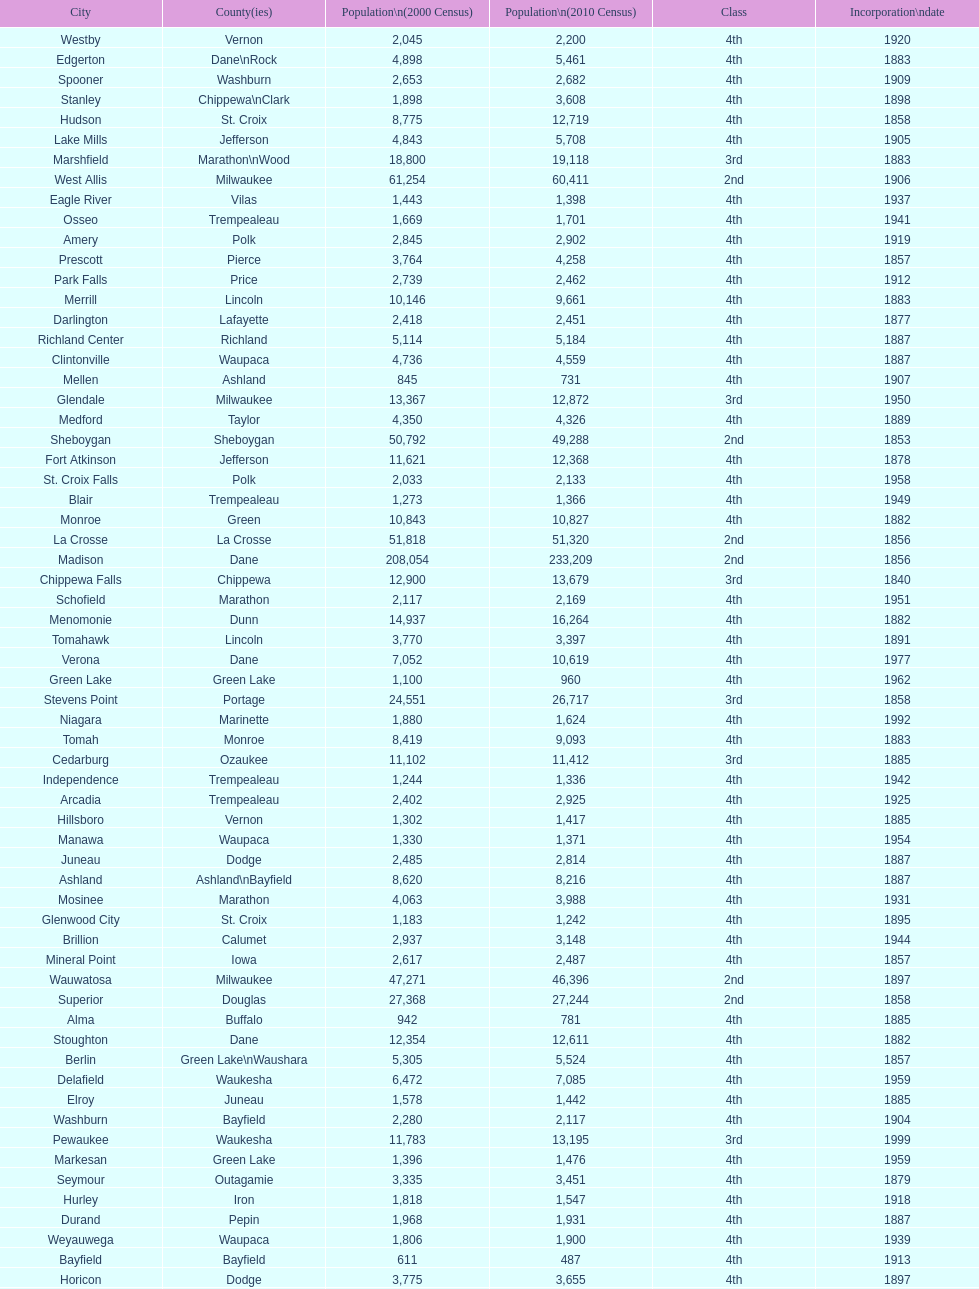Would you mind parsing the complete table? {'header': ['City', 'County(ies)', 'Population\\n(2000 Census)', 'Population\\n(2010 Census)', 'Class', 'Incorporation\\ndate'], 'rows': [['Westby', 'Vernon', '2,045', '2,200', '4th', '1920'], ['Edgerton', 'Dane\\nRock', '4,898', '5,461', '4th', '1883'], ['Spooner', 'Washburn', '2,653', '2,682', '4th', '1909'], ['Stanley', 'Chippewa\\nClark', '1,898', '3,608', '4th', '1898'], ['Hudson', 'St. Croix', '8,775', '12,719', '4th', '1858'], ['Lake Mills', 'Jefferson', '4,843', '5,708', '4th', '1905'], ['Marshfield', 'Marathon\\nWood', '18,800', '19,118', '3rd', '1883'], ['West Allis', 'Milwaukee', '61,254', '60,411', '2nd', '1906'], ['Eagle River', 'Vilas', '1,443', '1,398', '4th', '1937'], ['Osseo', 'Trempealeau', '1,669', '1,701', '4th', '1941'], ['Amery', 'Polk', '2,845', '2,902', '4th', '1919'], ['Prescott', 'Pierce', '3,764', '4,258', '4th', '1857'], ['Park Falls', 'Price', '2,739', '2,462', '4th', '1912'], ['Merrill', 'Lincoln', '10,146', '9,661', '4th', '1883'], ['Darlington', 'Lafayette', '2,418', '2,451', '4th', '1877'], ['Richland Center', 'Richland', '5,114', '5,184', '4th', '1887'], ['Clintonville', 'Waupaca', '4,736', '4,559', '4th', '1887'], ['Mellen', 'Ashland', '845', '731', '4th', '1907'], ['Glendale', 'Milwaukee', '13,367', '12,872', '3rd', '1950'], ['Medford', 'Taylor', '4,350', '4,326', '4th', '1889'], ['Sheboygan', 'Sheboygan', '50,792', '49,288', '2nd', '1853'], ['Fort Atkinson', 'Jefferson', '11,621', '12,368', '4th', '1878'], ['St. Croix Falls', 'Polk', '2,033', '2,133', '4th', '1958'], ['Blair', 'Trempealeau', '1,273', '1,366', '4th', '1949'], ['Monroe', 'Green', '10,843', '10,827', '4th', '1882'], ['La Crosse', 'La Crosse', '51,818', '51,320', '2nd', '1856'], ['Madison', 'Dane', '208,054', '233,209', '2nd', '1856'], ['Chippewa Falls', 'Chippewa', '12,900', '13,679', '3rd', '1840'], ['Schofield', 'Marathon', '2,117', '2,169', '4th', '1951'], ['Menomonie', 'Dunn', '14,937', '16,264', '4th', '1882'], ['Tomahawk', 'Lincoln', '3,770', '3,397', '4th', '1891'], ['Verona', 'Dane', '7,052', '10,619', '4th', '1977'], ['Green Lake', 'Green Lake', '1,100', '960', '4th', '1962'], ['Stevens Point', 'Portage', '24,551', '26,717', '3rd', '1858'], ['Niagara', 'Marinette', '1,880', '1,624', '4th', '1992'], ['Tomah', 'Monroe', '8,419', '9,093', '4th', '1883'], ['Cedarburg', 'Ozaukee', '11,102', '11,412', '3rd', '1885'], ['Independence', 'Trempealeau', '1,244', '1,336', '4th', '1942'], ['Arcadia', 'Trempealeau', '2,402', '2,925', '4th', '1925'], ['Hillsboro', 'Vernon', '1,302', '1,417', '4th', '1885'], ['Manawa', 'Waupaca', '1,330', '1,371', '4th', '1954'], ['Juneau', 'Dodge', '2,485', '2,814', '4th', '1887'], ['Ashland', 'Ashland\\nBayfield', '8,620', '8,216', '4th', '1887'], ['Mosinee', 'Marathon', '4,063', '3,988', '4th', '1931'], ['Glenwood City', 'St. Croix', '1,183', '1,242', '4th', '1895'], ['Brillion', 'Calumet', '2,937', '3,148', '4th', '1944'], ['Mineral Point', 'Iowa', '2,617', '2,487', '4th', '1857'], ['Wauwatosa', 'Milwaukee', '47,271', '46,396', '2nd', '1897'], ['Superior', 'Douglas', '27,368', '27,244', '2nd', '1858'], ['Alma', 'Buffalo', '942', '781', '4th', '1885'], ['Stoughton', 'Dane', '12,354', '12,611', '4th', '1882'], ['Berlin', 'Green Lake\\nWaushara', '5,305', '5,524', '4th', '1857'], ['Delafield', 'Waukesha', '6,472', '7,085', '4th', '1959'], ['Elroy', 'Juneau', '1,578', '1,442', '4th', '1885'], ['Washburn', 'Bayfield', '2,280', '2,117', '4th', '1904'], ['Pewaukee', 'Waukesha', '11,783', '13,195', '3rd', '1999'], ['Markesan', 'Green Lake', '1,396', '1,476', '4th', '1959'], ['Seymour', 'Outagamie', '3,335', '3,451', '4th', '1879'], ['Hurley', 'Iron', '1,818', '1,547', '4th', '1918'], ['Durand', 'Pepin', '1,968', '1,931', '4th', '1887'], ['Weyauwega', 'Waupaca', '1,806', '1,900', '4th', '1939'], ['Bayfield', 'Bayfield', '611', '487', '4th', '1913'], ['Horicon', 'Dodge', '3,775', '3,655', '4th', '1897'], ['Franklin', 'Milwaukee', '29,494', '35,451', '3rd', '1956'], ['Manitowoc', 'Manitowoc', '34,053', '33,736', '3rd', '1870'], ['Prairie du Chien', 'Crawford', '6,018', '5,911', '4th', '1872'], ['Galesville', 'Trempealeau', '1,427', '1,481', '4th', '1942'], ['Cornell', 'Chippewa', '1,466', '1,467', '4th', '1956'], ['Thorp', 'Clark', '1,536', '1,621', '4th', '1948'], ['Algoma', 'Kewaunee', '3,357', '3,167', '4th', '1879'], ['Oshkosh', 'Winnebago', '62,916', '66,083', '2nd', '1853'], ['Kewaunee', 'Kewaunee', '2,806', '2,952', '4th', '1883'], ['Oconomowoc', 'Waukesha', '12,382', '15,712', '3rd', '1875'], ['Evansville', 'Rock', '4,039', '5,012', '4th', '1896'], ['Kaukauna', 'Outagamie', '12,983', '15,462', '3rd', '1885'], ['Neenah', 'Winnebago', '24,507', '25,501', '3rd', '1873'], ['Chilton', 'Calumet', '3,708', '3,933', '4th', '1877'], ['Sparta', 'Monroe', '8,648', '9,522', '4th', '1883'], ['Appleton', 'Calumet\\nOutagamie\\nWinnebago', '70,087', '72,623', '2nd', '1857'], ['Crandon', 'Forest', '1,961', '1,920', '4th', '1898'], ['Black River Falls', 'Jackson', '3,618', '3,622', '4th', '1883'], ['De Pere', 'Brown', '20,559', '23,800', '3rd', '1883'], ['Oconto Falls', 'Oconto', '2,843', '2,891', '4th', '1919'], ['New Holstein', 'Calumet', '3,301', '3,236', '4th', '1889'], ['Delavan', 'Walworth', '7,956', '8,463', '4th', '1897'], ['Adams', 'Adams', '1,831', '1,967', '4th', '1926'], ['Baraboo', 'Sauk', '10,711', '12,048', '3rd', '1882'], ['Gillett', 'Oconto', '1,262', '1,386', '4th', '1944'], ['Menasha', 'Calumet\\nWinnebago', '16,331', '17,353', '3rd', '1874'], ['Barron', 'Barron', '3,248', '3,423', '4th', '1887'], ['Waterloo', 'Jefferson', '3,259', '3,333', '4th', '1962'], ['Marion', 'Shawano\\nWaupaca', '1,297', '1,260', '4th', '1898'], ['Cuba City', 'Grant\\nLafayette', '2,156', '2,086', '4th', '1925'], ['New Berlin', 'Waukesha', '38,220', '39,584', '3rd', '1959'], ['Shawano', 'Shawano', '8,298', '9,305', '4th', '1874'], ['Elkhorn', 'Walworth', '7,305', '10,084', '4th', '1897'], ['Mayville', 'Dodge', '4,902', '5,154', '4th', '1885'], ['Wausau', 'Marathon', '38,426', '39,106', '3rd', '1872'], ['South Milwaukee', 'Milwaukee', '21,256', '21,156', '4th', '1897'], ['Beaver Dam', 'Dodge', '15,169', '16,243', '4th', '1856'], ['Fox Lake', 'Dodge', '1,454', '1,519', '4th', '1938'], ['Beloit', 'Rock', '35,775', '36,966', '3rd', '1857'], ['Fitchburg', 'Dane', '20,501', '25,260', '4th', '1983'], ['Whitewater', 'Jefferson\\nWalworth', '13,437', '14,390', '4th', '1885'], ['Omro', 'Winnebago', '3,177', '3,517', '4th', '1944'], ['Viroqua', 'Vernon', '4,335', '5,079', '4th', '1885'], ['Plymouth', 'Sheboygan', '7,781', '8,445', '4th', '1877'], ['Two Rivers', 'Manitowoc', '12,639', '11,712', '3rd', '1878'], ['Wisconsin Dells', 'Adams\\nColumbia\\nJuneau\\nSauk', '2,418', '2,678', '4th', '1925'], ['Cudahy', 'Milwaukee', '18,429', '18,267', '3rd', '1906'], ['Lodi', 'Columbia', '2,882', '3,050', '4th', '1941'], ['New Lisbon', 'Juneau', '1,436', '2,554', '4th', '1889'], ['Neillsville', 'Clark', '2,731', '2,463', '4th', '1882'], ['Shullsburg', 'Lafayette', '1,246', '1,226', '4th', '1889'], ['Brookfield', 'Waukesha', '38,649', '37,920', '2nd', '1954'], ['West Bend', 'Washington', '28,152', '31,078', '3rd', '1885'], ['Fountain City', 'Buffalo', '983', '859', '4th', '1889'], ['Portage', 'Columbia', '9,728', '10,324', '4th', '1854'], ['Shell Lake', 'Washburn', '1,309', '1,347', '4th', '1961'], ['Lancaster', 'Grant', '4,070', '3,868', '4th', '1878'], ['Abbotsford', 'Clark\\nMarathon', '1,956', '2,310', '4th', '1965'], ['Oak Creek', 'Milwaukee', '28,456', '34,451', '3rd', '1955'], ['Waukesha', 'Waukesha', '64,825', '70,718', '2nd', '1895'], ['Loyal', 'Clark', '1,308', '1,261', '4th', '1948'], ['Wisconsin Rapids', 'Wood', '18,435', '18,367', '3rd', '1869'], ['Boscobel', 'Grant', '3,047', '3,231', '4th', '1873'], ['Green Bay', 'Brown', '102,767', '104,057', '2nd', '1854'], ['Fennimore', 'Grant', '2,387', '2,497', '4th', '1919'], ['Cumberland', 'Barron', '2,280', '2,170', '4th', '1885'], ['Hayward', 'Sawyer', '2,129', '2,318', '4th', '1915'], ['Greenwood', 'Clark', '1,079', '1,026', '4th', '1891'], ['Buffalo City', 'Buffalo', '1,040', '1,023', '4th', '1859'], ['Lake Geneva', 'Walworth', '7,148', '7,651', '4th', '1883'], ['Princeton', 'Green Lake', '1,504', '1,214', '4th', '1920'], ['Waupaca', 'Waupaca', '5,676', '6,069', '4th', '1878'], ['Rhinelander', 'Oneida', '7,735', '7,798', '4th', '1894'], ['Owen', 'Clark', '936', '940', '4th', '1925'], ['Augusta', 'Eau Claire', '1,460', '1,550', '4th', '1885'], ['Milton', 'Rock', '5,132', '5,546', '4th', '1969'], ['Onalaska', 'La Crosse', '14,839', '17,736', '4th', '1887'], ['Middleton', 'Dane', '15,770', '17,442', '3rd', '1963'], ['New London', 'Outagamie\\nWaupaca', '7,085', '7,295', '4th', '1877'], ['Milwaukee', 'Milwaukee\\nWashington\\nWaukesha', '596,974', '594,833', '1st', '1846'], ['Wautoma', 'Waushara', '1,998', '2,218', '4th', '1901'], ['Port Washington', 'Ozaukee', '10,467', '11,250', '4th', '1882'], ['Monona', 'Dane', '8,018', '7,533', '4th', '1969'], ['Ladysmith', 'Rusk', '3,932', '3,414', '4th', '1905'], ['Mondovi', 'Buffalo', '2,634', '2,777', '4th', '1889'], ['Marinette', 'Marinette', '11,749', '10,968', '3rd', '1887'], ['Muskego', 'Waukesha', '21,397', '24,135', '3rd', '1964'], ['Sheboygan Falls', 'Sheboygan', '6,772', '7,775', '4th', '1913'], ['Dodgeville', 'Iowa', '4,220', '4,698', '4th', '1889'], ['Mequon', 'Ozaukee', '22,643', '23,132', '4th', '1957'], ['Rice Lake', 'Barron', '8,312', '8,438', '4th', '1887'], ['Nekoosa', 'Wood', '2,590', '2,580', '4th', '1926'], ['Jefferson', 'Jefferson', '7,338', '7,973', '4th', '1878'], ['Platteville', 'Grant', '9,989', '11,224', '4th', '1876'], ['Mauston', 'Juneau', '3,740', '4,423', '4th', '1883'], ['Sun Prairie', 'Dane', '20,369', '29,364', '3rd', '1958'], ['Burlington', 'Racine\\nWalworth', '9,936', '10,464', '4th', '1900'], ['Greenfield', 'Milwaukee', '35,476', '36,720', '3rd', '1957'], ['Ripon', 'Fond du Lac', '7,450', '7,733', '4th', '1858'], ['Kiel', 'Calumet\\nManitowoc', '3,450', '3,738', '4th', '1920'], ['Chetek', 'Barron', '2,180', '2,221', '4th', '1891'], ['Watertown', 'Dodge\\nJefferson', '21,598', '23,861', '3rd', '1853'], ['Phillips', 'Price', '1,675', '1,478', '4th', '1891'], ['New Richmond', 'St. Croix', '6,310', '8,375', '4th', '1885'], ['Sturgeon Bay', 'Door', '9,437', '9,144', '4th', '1883'], ['Oconto', 'Oconto', '4,708', '4,513', '4th', '1869'], ['Janesville', 'Rock', '59,498', '63,575', '2nd', '1853'], ['Waupun', 'Dodge\\nFond du Lac', '10,944', '11,340', '4th', '1878'], ['Antigo', 'Langlade', '8,560', '8,234', '4th', '1885'], ['Reedsburg', 'Sauk', '7,827', '10,014', '4th', '1887'], ['Kenosha', 'Kenosha', '90,352', '99,218', '2nd', '1850'], ['St. Francis', 'Milwaukee', '8,662', '9,365', '4th', '1951'], ['Montreal', 'Iron', '838', '807', '4th', '1924'], ['Hartford', 'Dodge\\nWashington', '10,905', '14,223', '3rd', '1883'], ['Whitehall', 'Trempealeau', '1,651', '1,558', '4th', '1941'], ['Peshtigo', 'Marinette', '3,474', '3,502', '4th', '1903'], ['Columbus', 'Columbia\\nDodge', '4,479', '4,991', '4th', '1874'], ['Racine', 'Racine', '81,855', '78,860', '2nd', '1848'], ['Montello', 'Marquette', '1,397', '1,495', '4th', '1938'], ['Bloomer', 'Chippewa', '3,347', '3,539', '4th', '1920'], ['Eau Claire', 'Chippewa\\nEau Claire', '61,704', '65,883', '2nd', '1872'], ['River Falls', 'Pierce\\nSt. Croix', '12,560', '15,000', '3rd', '1875'], ['Fond du Lac', 'Fond du Lac', '42,203', '43,021', '2nd', '1852'], ['Pittsville', 'Wood', '866', '874', '4th', '1887'], ['Altoona', 'Eau Claire', '6,698', '6,706', '4th', '1887'], ['Colby', 'Clark\\nMarathon', '1,616', '1,852', '4th', '1891'], ['Brodhead', 'Green\\nRock', '3,180', '3,293', '4th', '1891']]} What was the first city to be incorporated into wisconsin? Chippewa Falls. 